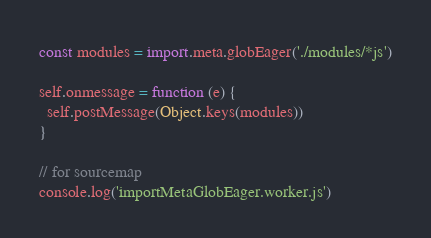Convert code to text. <code><loc_0><loc_0><loc_500><loc_500><_JavaScript_>const modules = import.meta.globEager('./modules/*js')

self.onmessage = function (e) {
  self.postMessage(Object.keys(modules))
}

// for sourcemap
console.log('importMetaGlobEager.worker.js')
</code> 